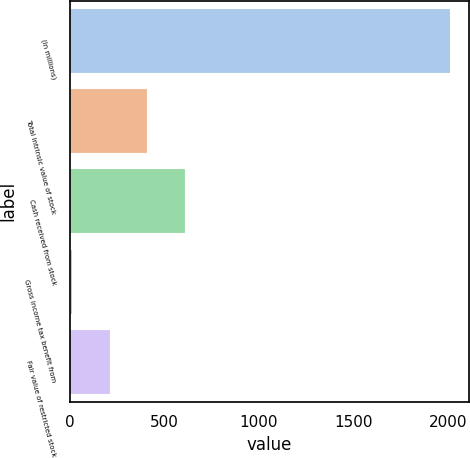Convert chart. <chart><loc_0><loc_0><loc_500><loc_500><bar_chart><fcel>(In millions)<fcel>Total intrinsic value of stock<fcel>Cash received from stock<fcel>Gross income tax benefit from<fcel>Fair value of restricted stock<nl><fcel>2011<fcel>410.2<fcel>610.3<fcel>10<fcel>210.1<nl></chart> 